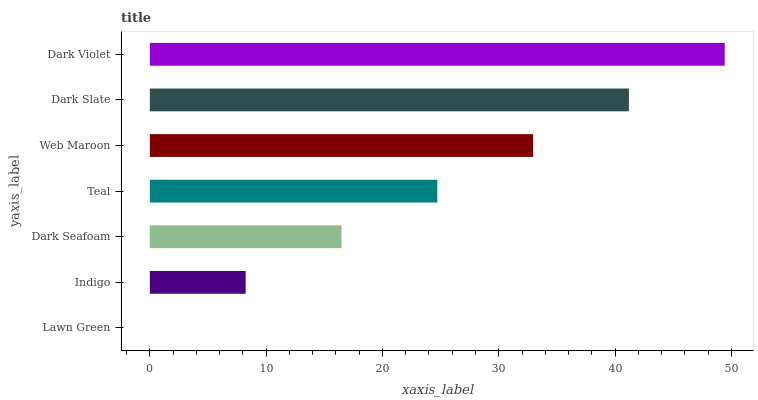Is Lawn Green the minimum?
Answer yes or no. Yes. Is Dark Violet the maximum?
Answer yes or no. Yes. Is Indigo the minimum?
Answer yes or no. No. Is Indigo the maximum?
Answer yes or no. No. Is Indigo greater than Lawn Green?
Answer yes or no. Yes. Is Lawn Green less than Indigo?
Answer yes or no. Yes. Is Lawn Green greater than Indigo?
Answer yes or no. No. Is Indigo less than Lawn Green?
Answer yes or no. No. Is Teal the high median?
Answer yes or no. Yes. Is Teal the low median?
Answer yes or no. Yes. Is Dark Slate the high median?
Answer yes or no. No. Is Lawn Green the low median?
Answer yes or no. No. 